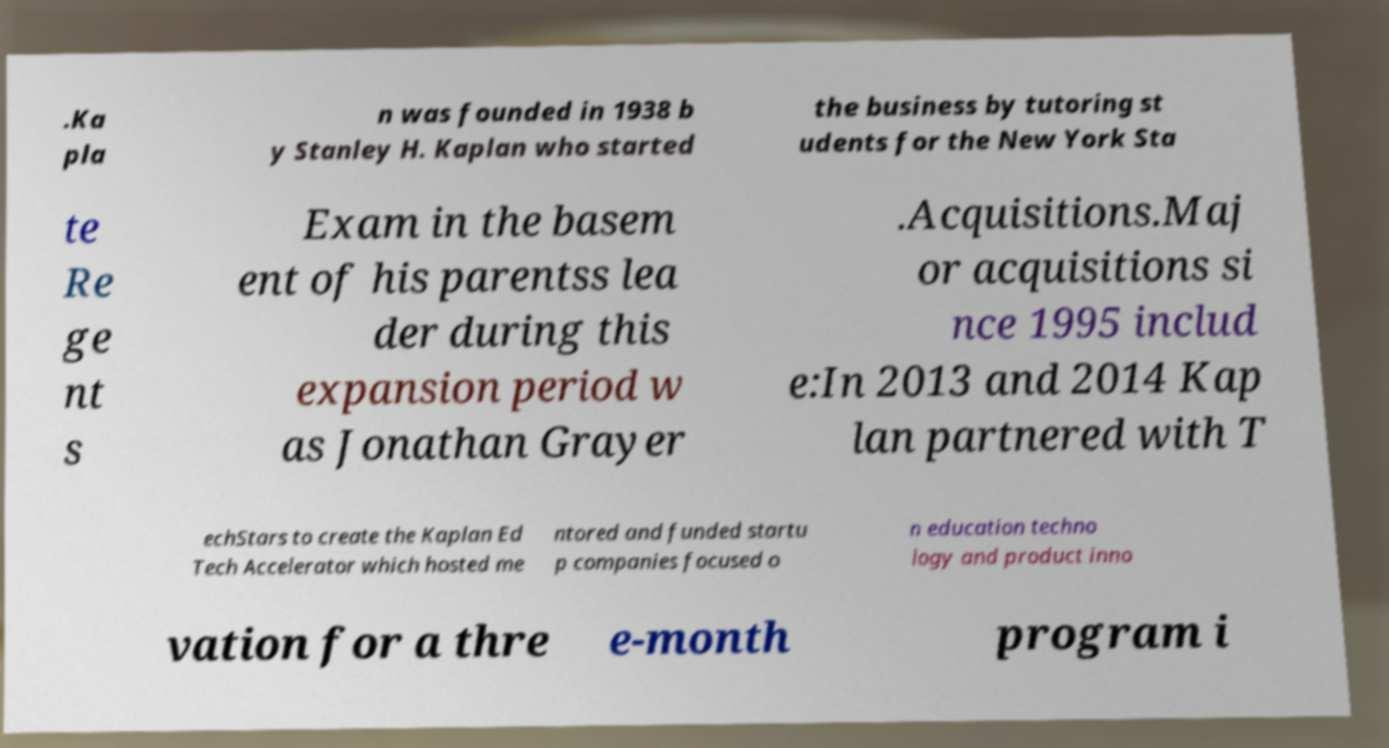Could you assist in decoding the text presented in this image and type it out clearly? .Ka pla n was founded in 1938 b y Stanley H. Kaplan who started the business by tutoring st udents for the New York Sta te Re ge nt s Exam in the basem ent of his parentss lea der during this expansion period w as Jonathan Grayer .Acquisitions.Maj or acquisitions si nce 1995 includ e:In 2013 and 2014 Kap lan partnered with T echStars to create the Kaplan Ed Tech Accelerator which hosted me ntored and funded startu p companies focused o n education techno logy and product inno vation for a thre e-month program i 